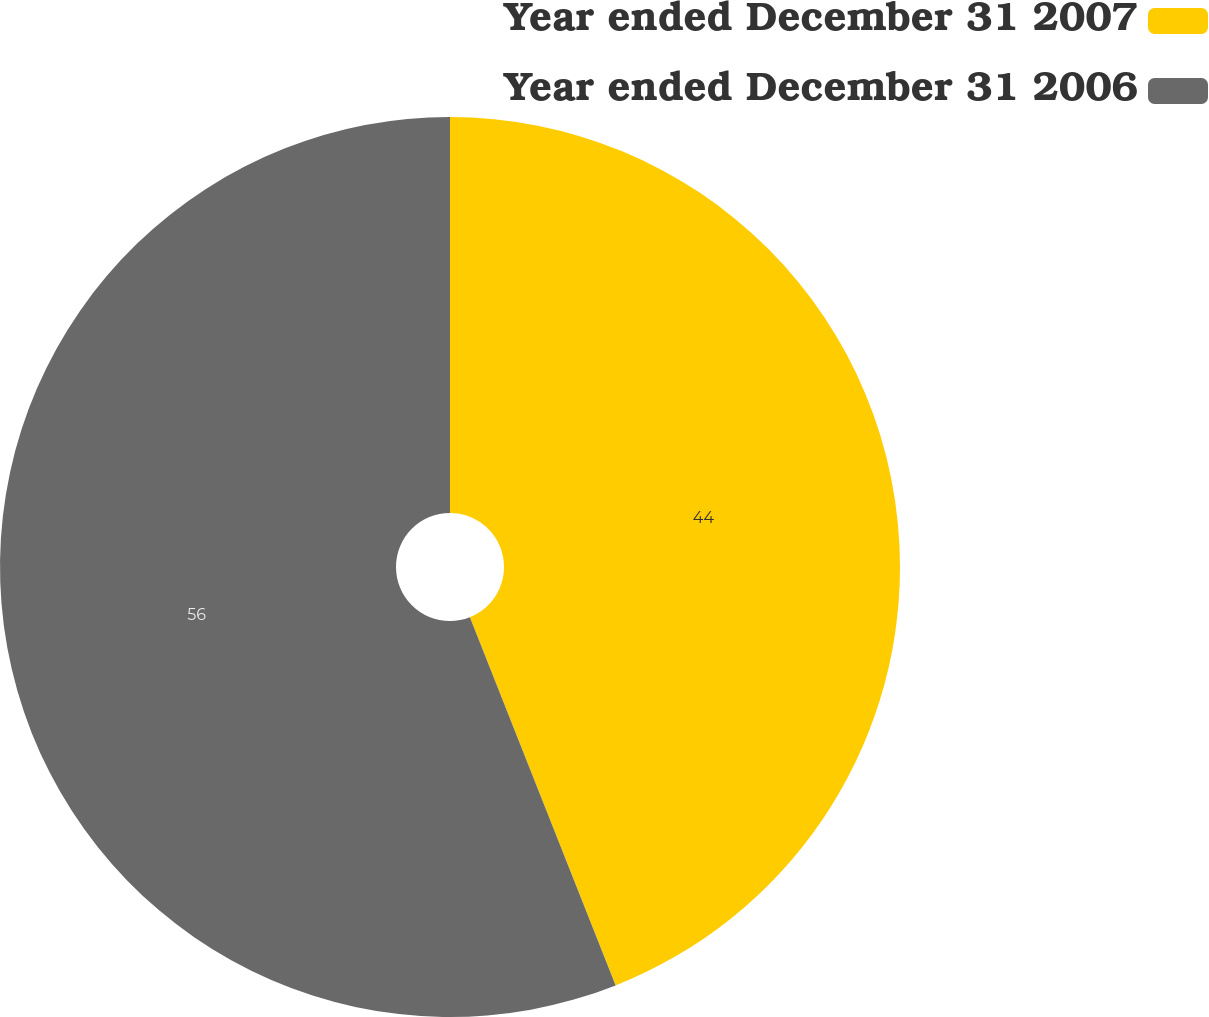Convert chart to OTSL. <chart><loc_0><loc_0><loc_500><loc_500><pie_chart><fcel>Year ended December 31 2007<fcel>Year ended December 31 2006<nl><fcel>44.0%<fcel>56.0%<nl></chart> 